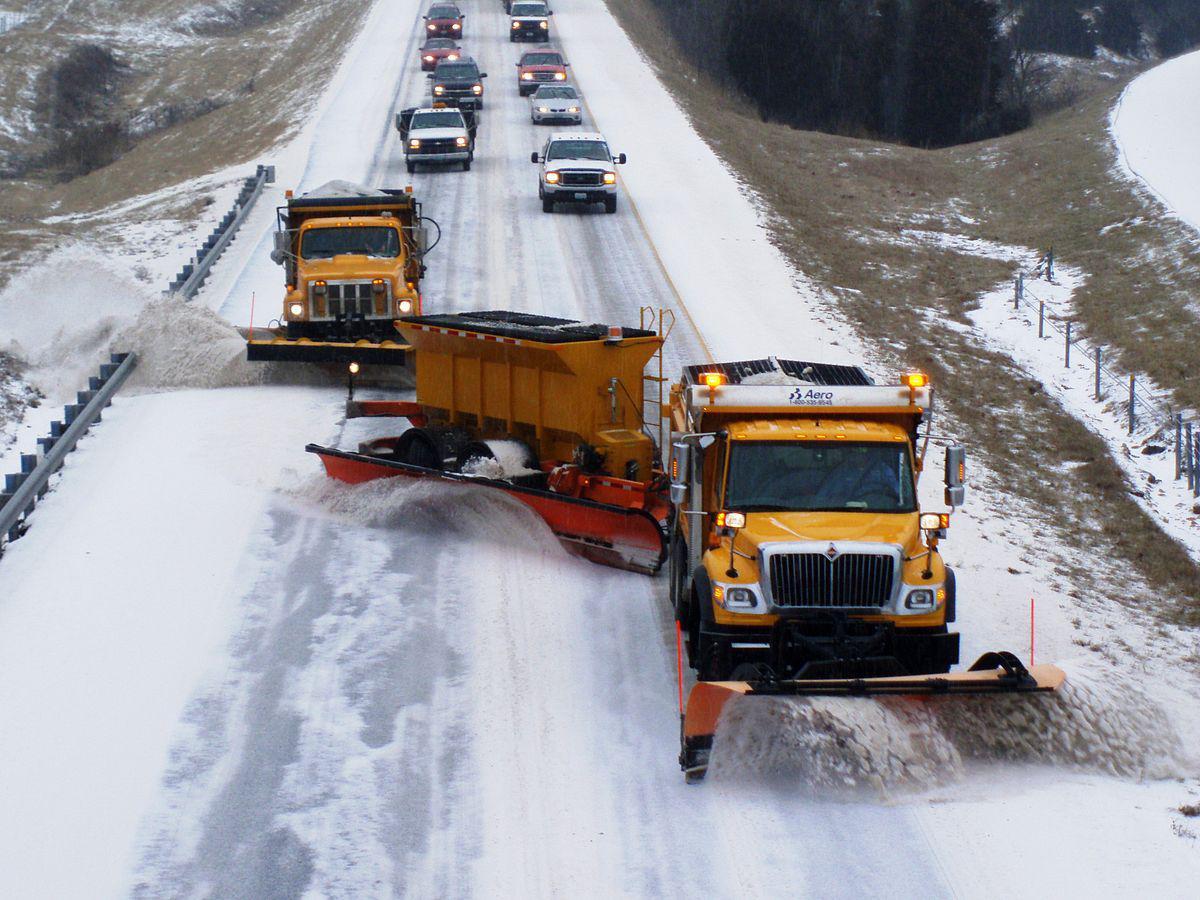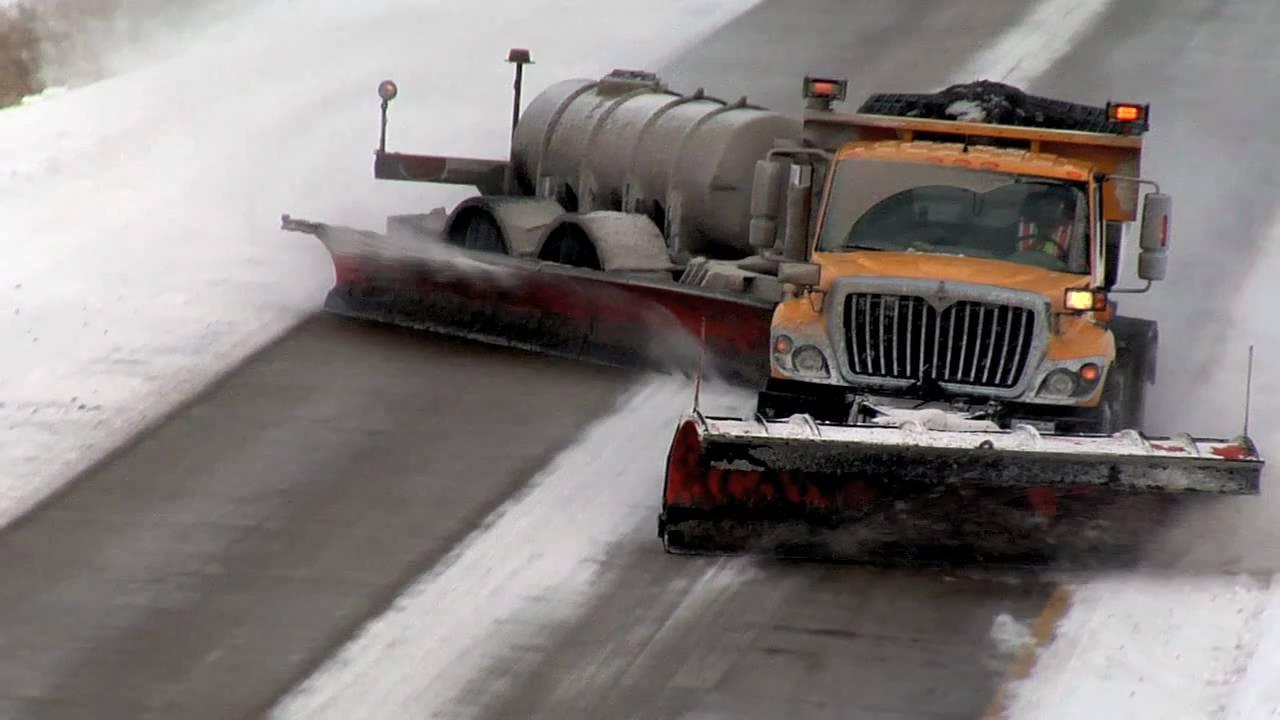The first image is the image on the left, the second image is the image on the right. Evaluate the accuracy of this statement regarding the images: "Both images feature in the foreground a tow plow pulled by a truck with a bright yellow cab.". Is it true? Answer yes or no. Yes. The first image is the image on the left, the second image is the image on the right. Given the left and right images, does the statement "There are more than three vehicles in the right image." hold true? Answer yes or no. No. 